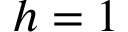<formula> <loc_0><loc_0><loc_500><loc_500>h = 1</formula> 